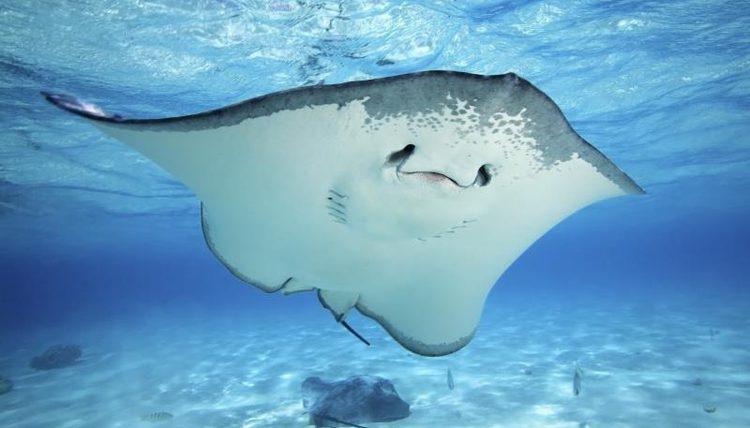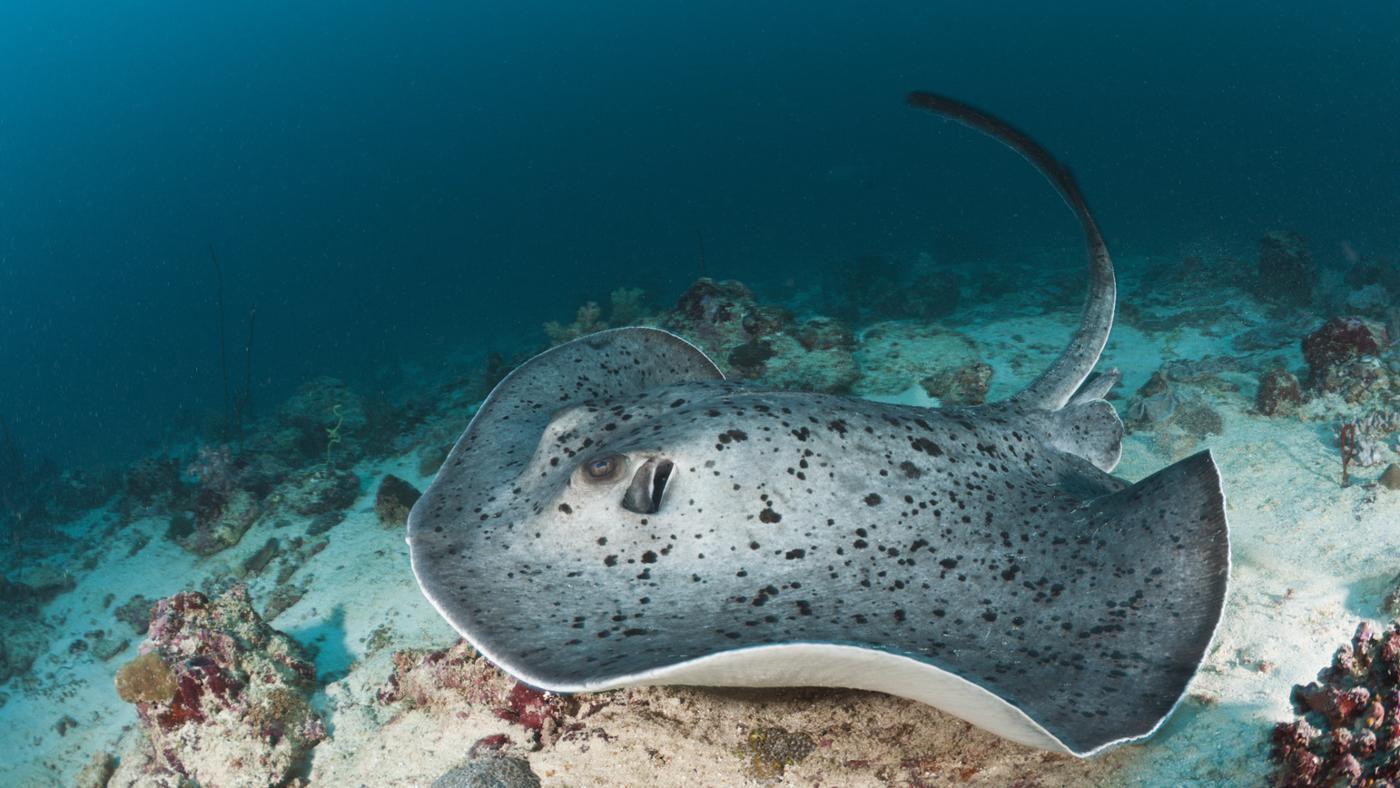The first image is the image on the left, the second image is the image on the right. For the images displayed, is the sentence "the left images shows a stingray swimming with the full under belly showing" factually correct? Answer yes or no. Yes. The first image is the image on the left, the second image is the image on the right. Considering the images on both sides, is "In one image there is a ray that is swimming very close to the ocean floor." valid? Answer yes or no. Yes. 